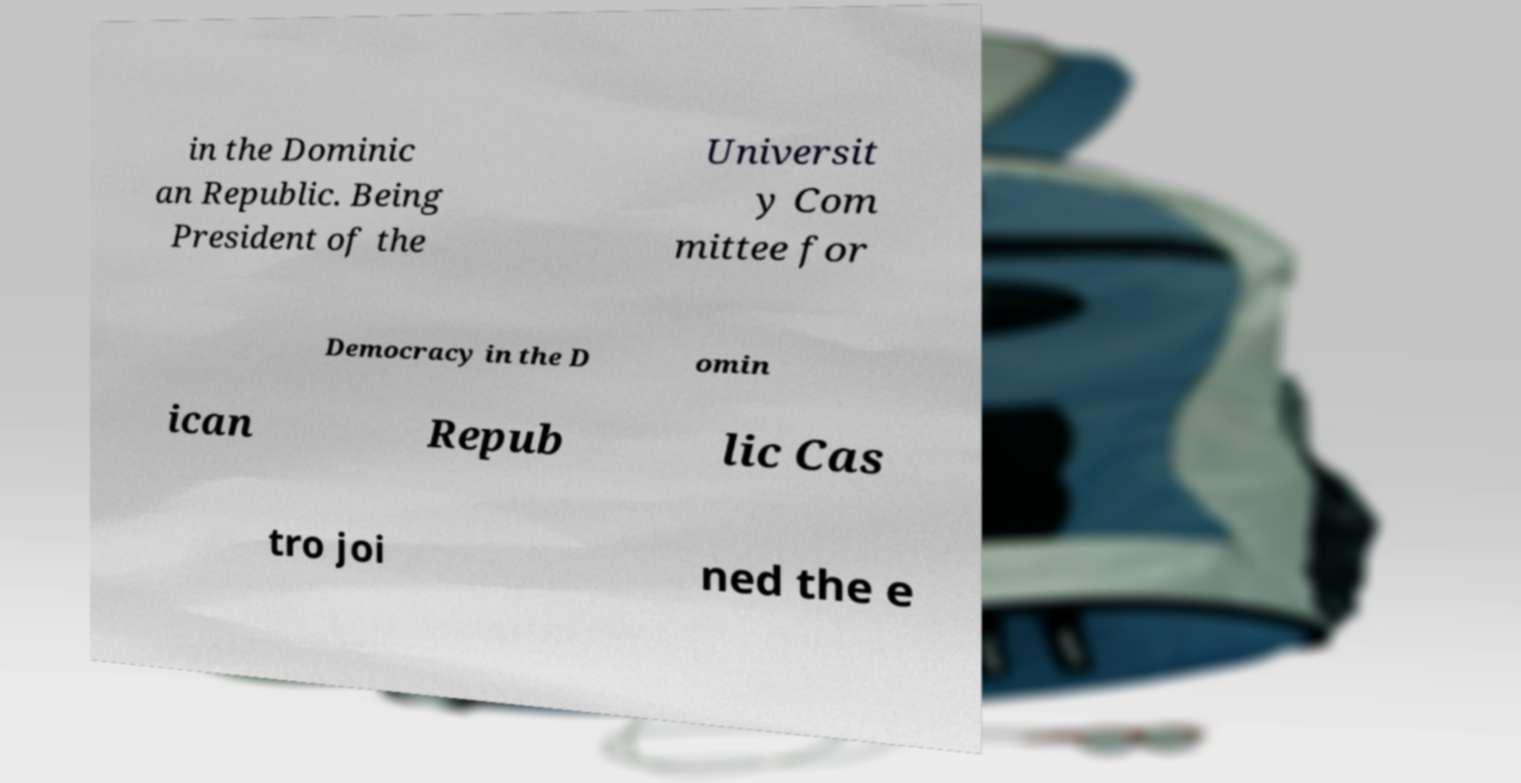Please identify and transcribe the text found in this image. in the Dominic an Republic. Being President of the Universit y Com mittee for Democracy in the D omin ican Repub lic Cas tro joi ned the e 